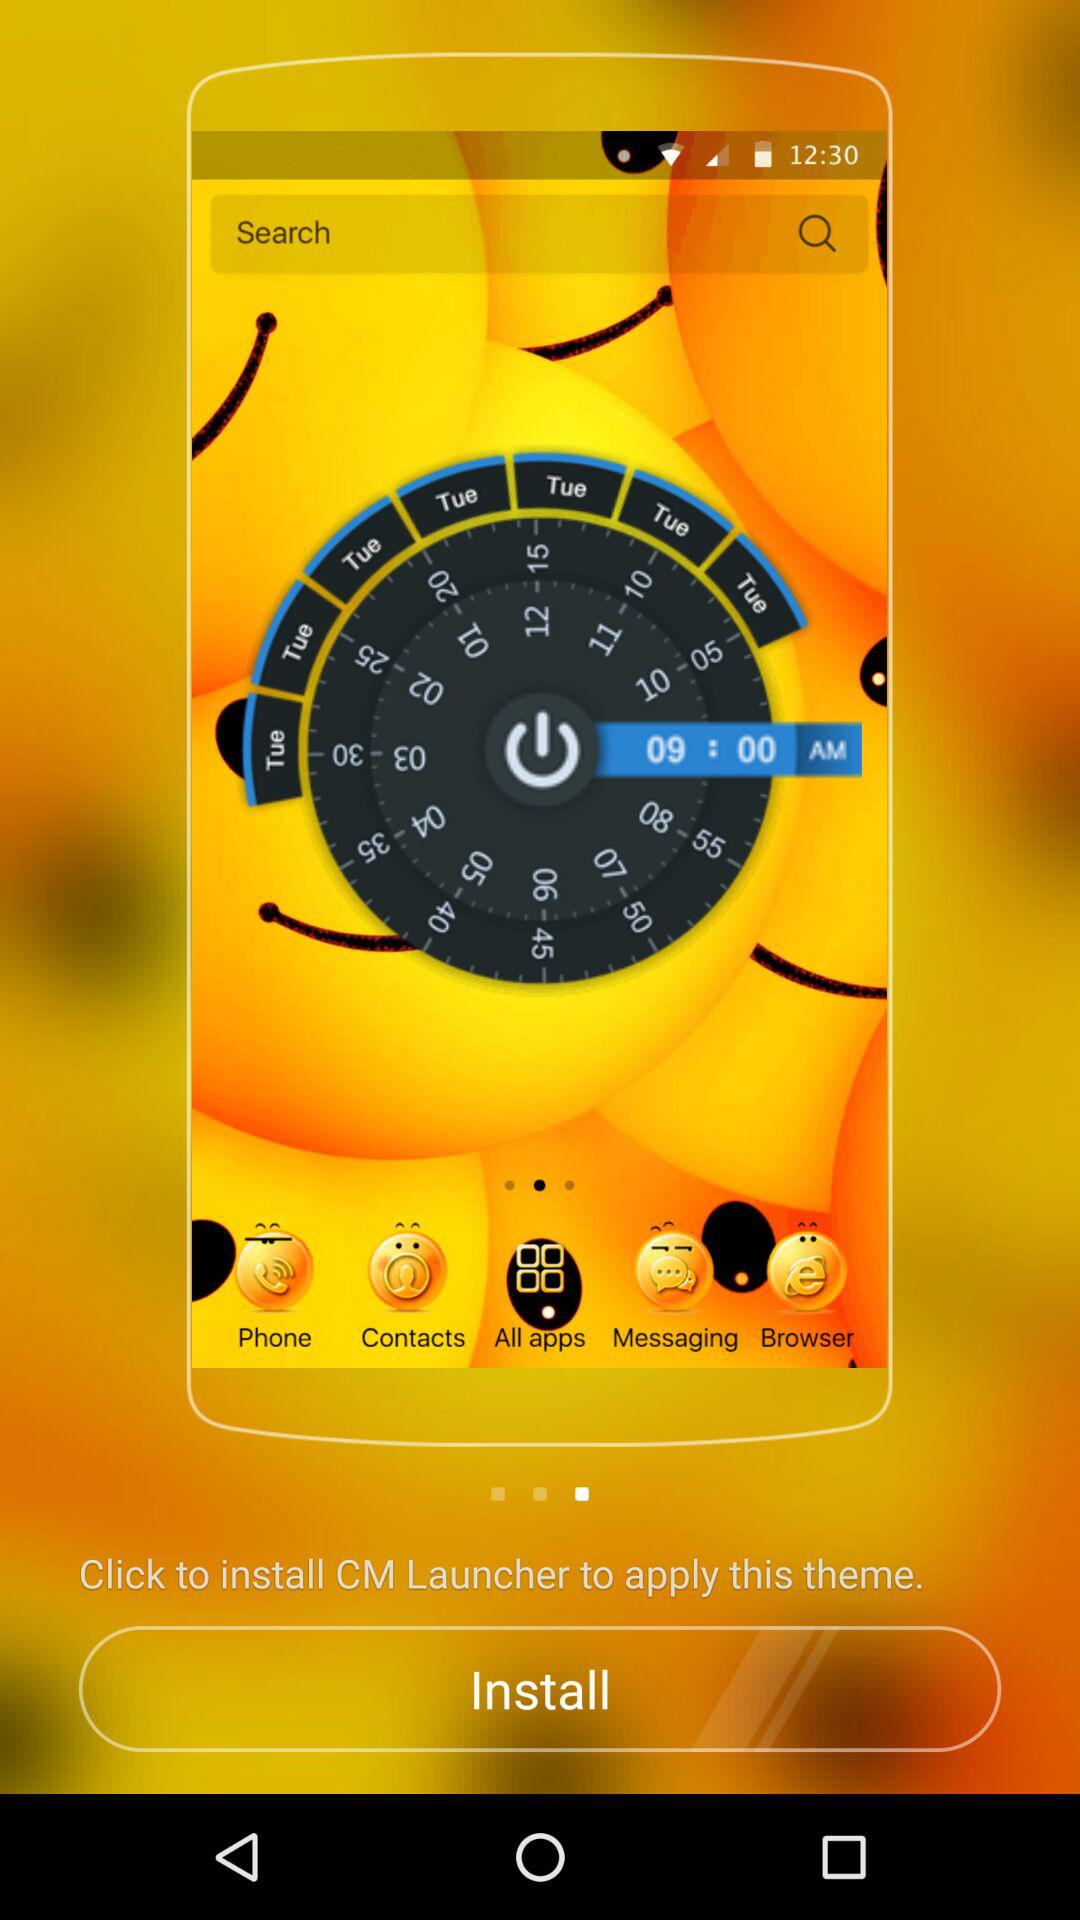What should I do to apply the theme? You should click to install "CM Launcher" to apply the theme. 